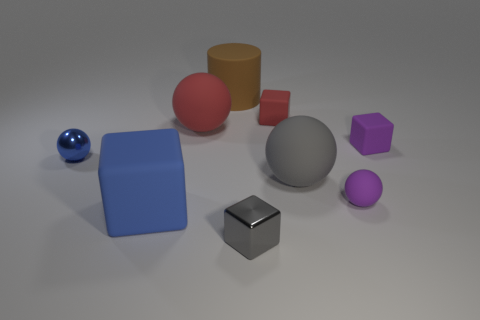There is a metallic sphere that is the same size as the gray block; what color is it?
Your answer should be compact. Blue. Is the size of the metallic thing right of the big red ball the same as the shiny thing that is left of the big brown matte cylinder?
Your answer should be compact. Yes. How big is the thing that is to the right of the tiny matte sphere that is behind the small shiny thing that is to the right of the blue ball?
Your answer should be very brief. Small. What is the shape of the shiny object that is behind the matte cube in front of the blue sphere?
Your answer should be very brief. Sphere. There is a small sphere behind the gray matte object; does it have the same color as the large rubber cube?
Your answer should be very brief. Yes. The block that is behind the small gray cube and in front of the blue metallic thing is what color?
Offer a terse response. Blue. Are there any small blue things made of the same material as the brown cylinder?
Provide a succinct answer. No. How big is the gray cube?
Provide a succinct answer. Small. There is a matte cube behind the tiny purple object right of the tiny rubber sphere; how big is it?
Your response must be concise. Small. What is the material of the gray thing that is the same shape as the tiny red rubber object?
Your answer should be compact. Metal. 